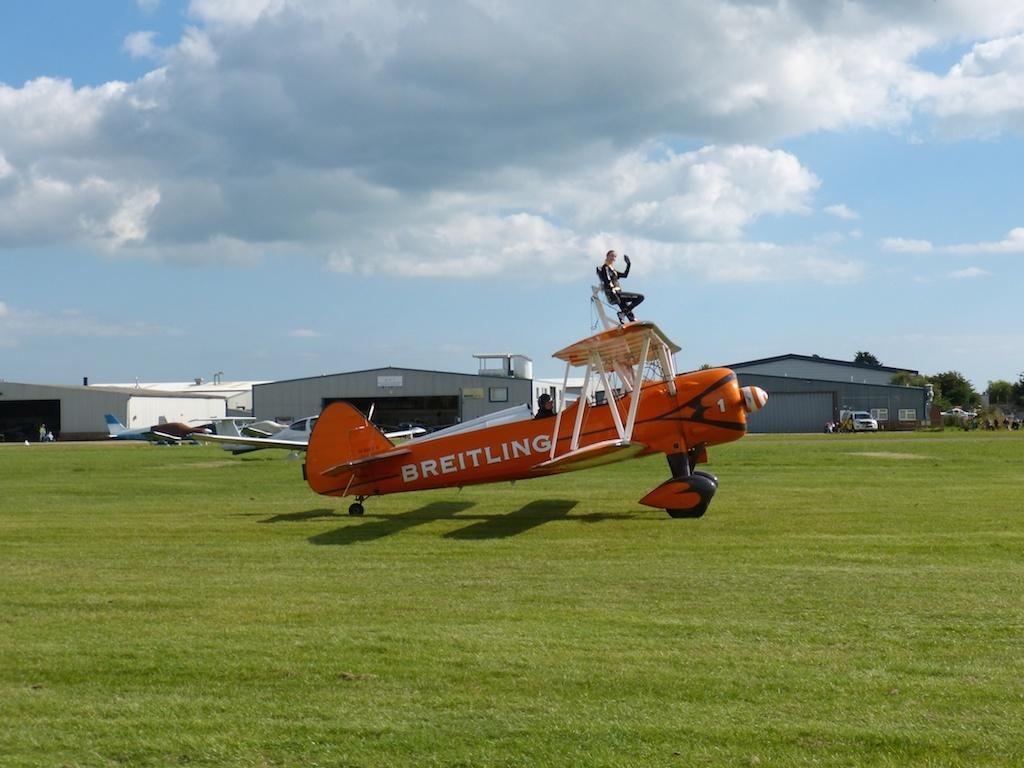<image>
Describe the image concisely. An orange plane that is owned by the company Breitling. 